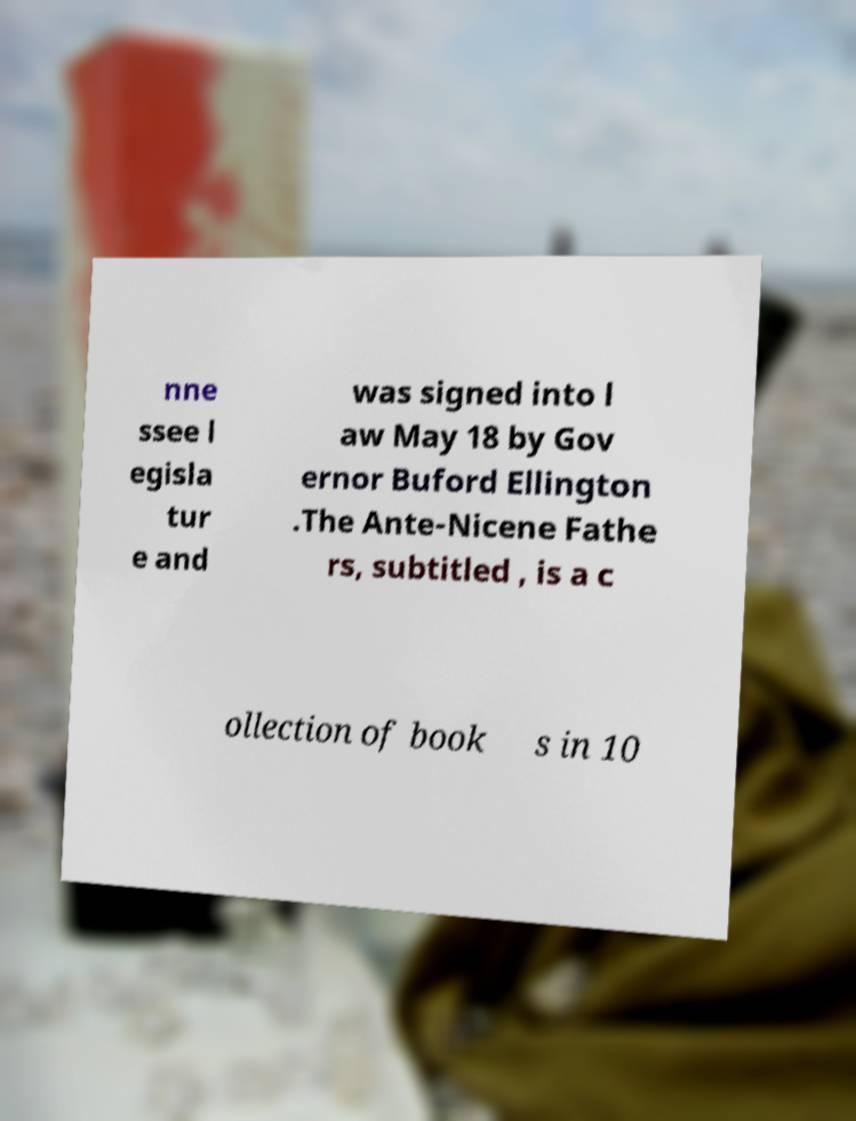There's text embedded in this image that I need extracted. Can you transcribe it verbatim? nne ssee l egisla tur e and was signed into l aw May 18 by Gov ernor Buford Ellington .The Ante-Nicene Fathe rs, subtitled , is a c ollection of book s in 10 